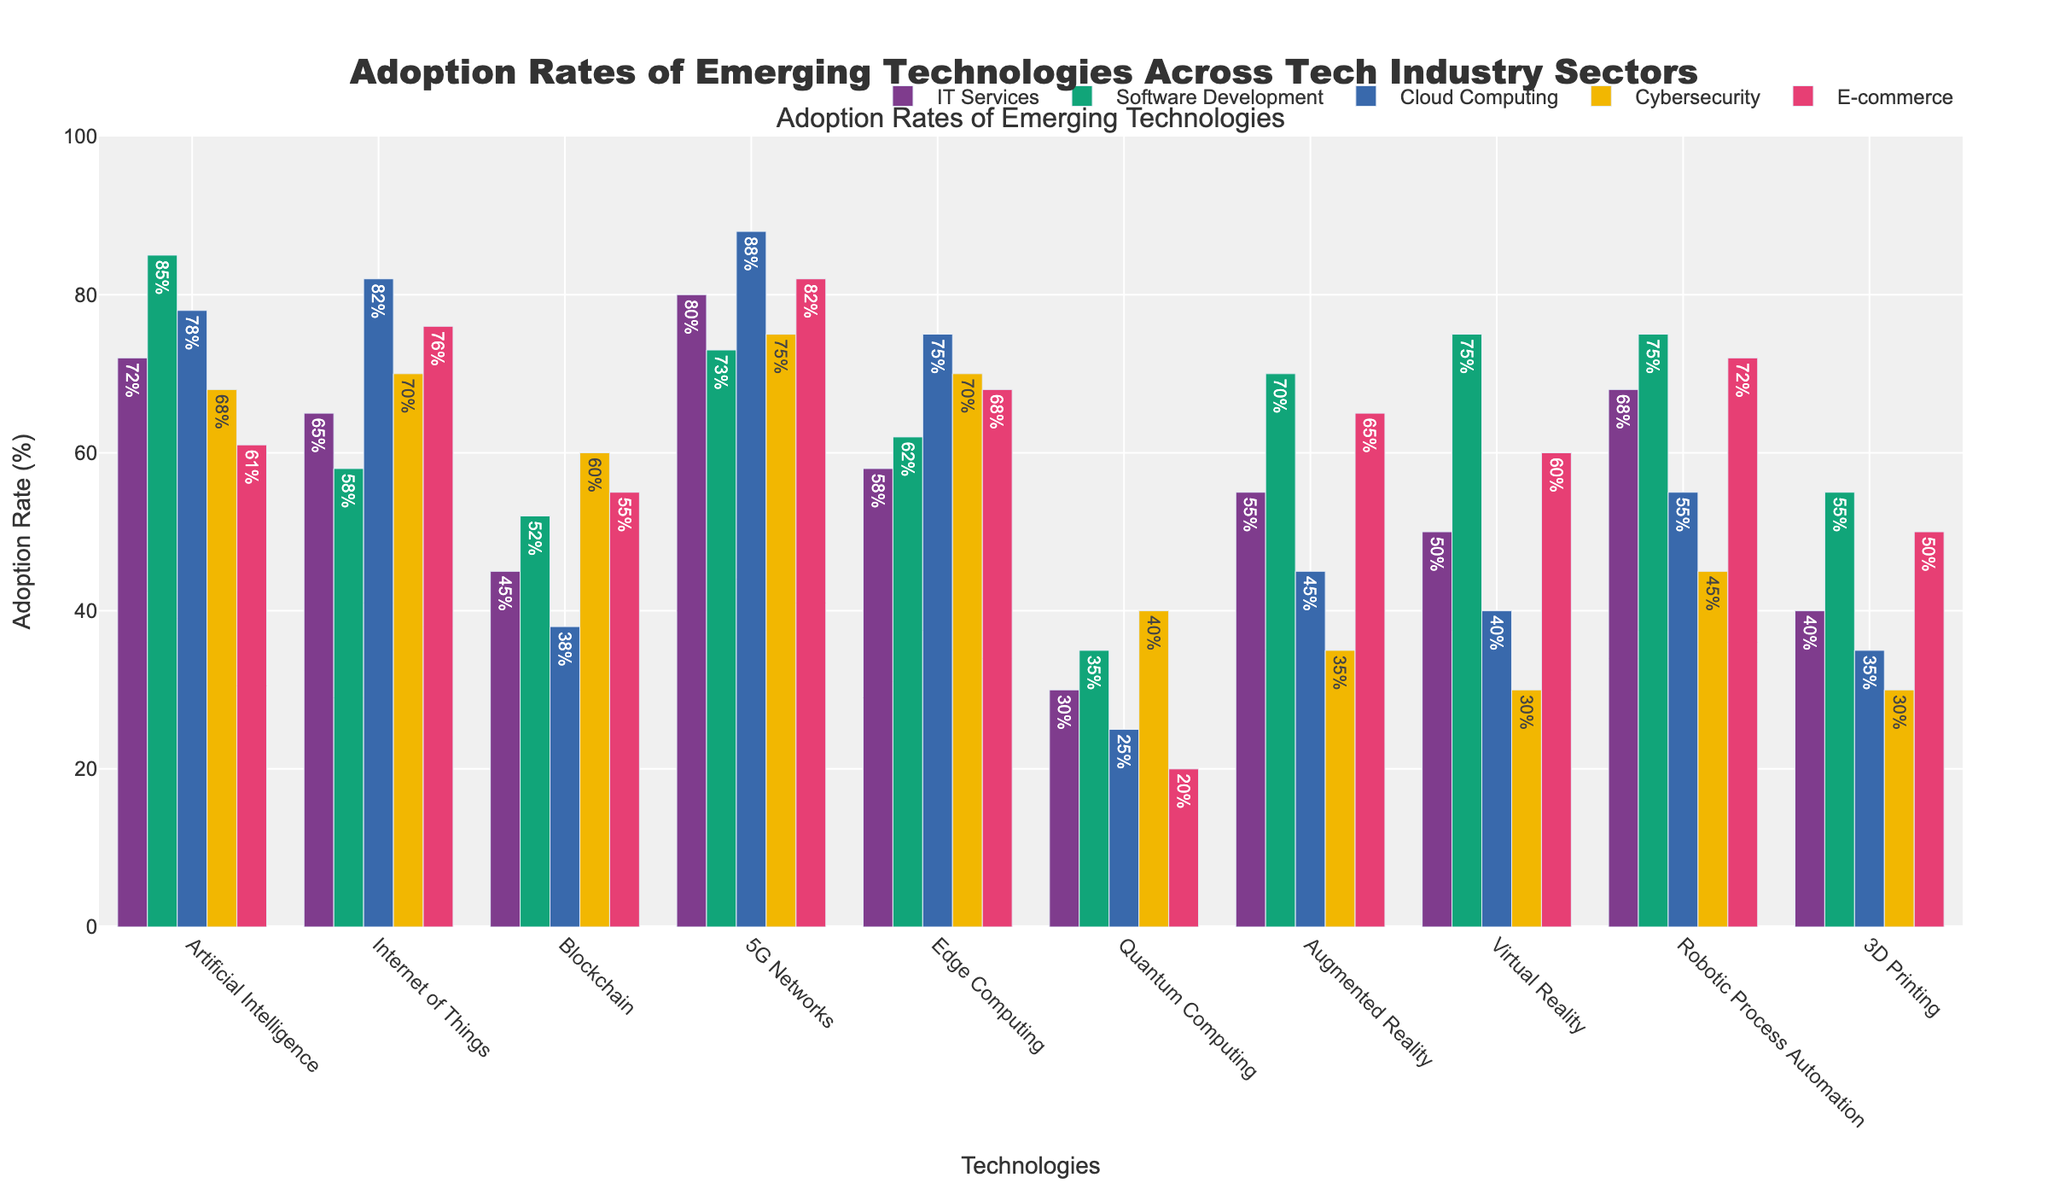Which technology has the highest adoption rate in Software Development? By checking the heights of the bars in the Software Development category, the technology with the highest adoption rate is Artificial Intelligence with a rate of 85%.
Answer: Artificial Intelligence Compare the adoption rates of 5G Networks and Artificial Intelligence in IT Services. Which one is higher? The height of the bar for 5G Networks in IT Services is 80%, while the bar for Artificial Intelligence is 72%. Thus, 5G Networks has a higher adoption rate in IT Services.
Answer: 5G Networks What is the average adoption rate of Quantum Computing across all sectors? To find the average adoption rate, sum the adoption rates in IT Services (30), Software Development (35), Cloud Computing (25), Cybersecurity (40), and E-commerce (20), then divide by the number of sectors (5). The average = (30+35+25+40+20) / 5 = 30.
Answer: 30 Which technology has the lowest adoption rate in Cloud Computing? The technology with the lowest bar height in Cloud Computing is Quantum Computing with an adoption rate of 25%.
Answer: Quantum Computing Compare the adoption rates of Internet of Things and Edge Computing in E-commerce. Which one is higher? The height of the bar for Internet of Things in E-commerce is 76%, while for Edge Computing it is 68%. Thus, Internet of Things has a higher adoption rate in E-commerce.
Answer: Internet of Things What is the total adoption rate of Blockchain across all sectors? Summing up the adoption rates in IT Services (45), Software Development (52), Cloud Computing (38), Cybersecurity (60), and E-commerce (55) gives the total adoption rate. Total = 45+52+38+60+55 = 250.
Answer: 250 Between IT Services and Cybersecurity, which sector has a higher adoption rate of Robotic Process Automation? The height of the bar for Robotic Process Automation in IT Services is 68%, while in Cybersecurity, it is 45%. Thus, IT Services has a higher adoption rate.
Answer: IT Services Is the adoption rate of Augmented Reality higher in Software Development or in Cloud Computing? The height of the bar for Augmented Reality in Software Development is 70%, while in Cloud Computing, it is 45%. Therefore, it is higher in Software Development.
Answer: Software Development Which technology has the smallest difference in adoption rates between IT Services and E-commerce? The differences in adoption rates are: Artificial Intelligence (11%), Internet of Things (11%), Blockchain (10%), 5G Networks (2%), Edge Computing (10%), Quantum Computing (10%), Augmented Reality (10%), Virtual Reality (10%), Robotic Process Automation (4%), 3D Printing (10%). 5G Networks has the smallest difference of 2%.
Answer: 5G Networks Compare the height and color of the bars representing Artificial Intelligence in Cybersecurity and Virtual Reality in E-commerce. The height of the bar for Artificial Intelligence in Cybersecurity is 68% and is colored to reflect that sector. The height of the bar for Virtual Reality in E-commerce is 60% and is also colored according to its sector. Artificial Intelligence in Cybersecurity is taller.
Answer: Artificial Intelligence in Cybersecurity 